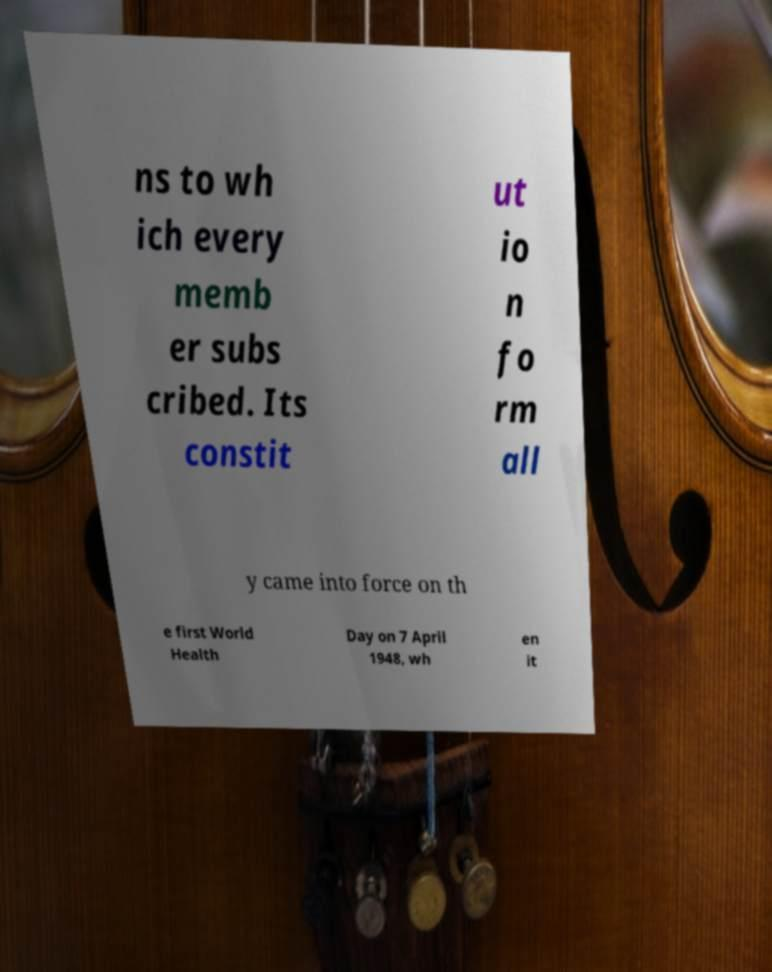There's text embedded in this image that I need extracted. Can you transcribe it verbatim? ns to wh ich every memb er subs cribed. Its constit ut io n fo rm all y came into force on th e first World Health Day on 7 April 1948, wh en it 